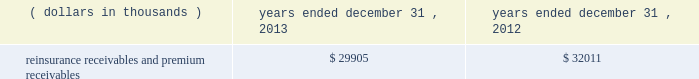In addition , the company has reclassified the following amounts from 201cdistributions from other invested assets 201d included in cash flows from investing activities to 201cdistribution of limited partnership income 201d included in cash flows from operations for interim reporting periods of 2013 : $ 33686 thousand for the three months ended march 31 , 2013 ; $ 9409 thousand and $ 43095 thousand for the three months and six months ended june 30 , 2013 , respectively ; and $ 5638 thousand and $ 48733 thousand for the three months and nine months ended september 30 , 2013 , respectively .
Investments .
Fixed maturity and equity security investments available for sale , at market value , reflect unrealized appreciation and depreciation , as a result of temporary changes in market value during the period , in shareholders 2019 equity , net of income taxes in 201caccumulated other comprehensive income ( loss ) 201d in the consolidated balance sheets .
Fixed maturity and equity securities carried at fair value reflect fair value re- measurements as net realized capital gains and losses in the consolidated statements of operations and comprehensive income ( loss ) .
The company records changes in fair value for its fixed maturities available for sale , at market value through shareholders 2019 equity , net of taxes in accumulated other comprehensive income ( loss ) since cash flows from these investments will be primarily used to settle its reserve for losses and loss adjustment expense liabilities .
The company anticipates holding these investments for an extended period as the cash flow from interest and maturities will fund the projected payout of these liabilities .
Fixed maturities carried at fair value represent a portfolio of convertible bond securities , which have characteristics similar to equity securities and at times , designated foreign denominated fixed maturity securities , which will be used to settle loss and loss adjustment reserves in the same currency .
The company carries all of its equity securities at fair value except for mutual fund investments whose underlying investments are comprised of fixed maturity securities .
For equity securities , available for sale , at fair value , the company reflects changes in value as net realized capital gains and losses since these securities may be sold in the near term depending on financial market conditions .
Interest income on all fixed maturities and dividend income on all equity securities are included as part of net investment income in the consolidated statements of operations and comprehensive income ( loss ) .
Unrealized losses on fixed maturities , which are deemed other-than-temporary and related to the credit quality of a security , are charged to net income ( loss ) as net realized capital losses .
Short-term investments are stated at cost , which approximates market value .
Realized gains or losses on sales of investments are determined on the basis of identified cost .
For non- publicly traded securities , market prices are determined through the use of pricing models that evaluate securities relative to the u.s .
Treasury yield curve , taking into account the issue type , credit quality , and cash flow characteristics of each security .
For publicly traded securities , market value is based on quoted market prices or valuation models that use observable market inputs .
When a sector of the financial markets is inactive or illiquid , the company may use its own assumptions about future cash flows and risk-adjusted discount rates to determine fair value .
Retrospective adjustments are employed to recalculate the values of asset-backed securities .
Each acquisition lot is reviewed to recalculate the effective yield .
The recalculated effective yield is used to derive a book value as if the new yield were applied at the time of acquisition .
Outstanding principal factors from the time of acquisition to the adjustment date are used to calculate the prepayment history for all applicable securities .
Conditional prepayment rates , computed with life to date factor histories and weighted average maturities , are used to effect the calculation of projected and prepayments for pass-through security types .
Other invested assets include limited partnerships , rabbi trusts and an affiliated entity .
Limited partnerships and the affiliated entity are accounted for under the equity method of accounting , which can be recorded on a monthly or quarterly lag .
Uncollectible receivable balances .
The company provides reserves for uncollectible reinsurance recoverable and premium receivable balances based on management 2019s assessment of the collectability of the outstanding balances .
Such reserves are presented in the table below for the periods indicated. .

For the years ended december 312013 and 2012 what was the change in the reinsurance receivables and premium receivables in thousands? 
Computations: (29905 - 32011)
Answer: -2106.0. 